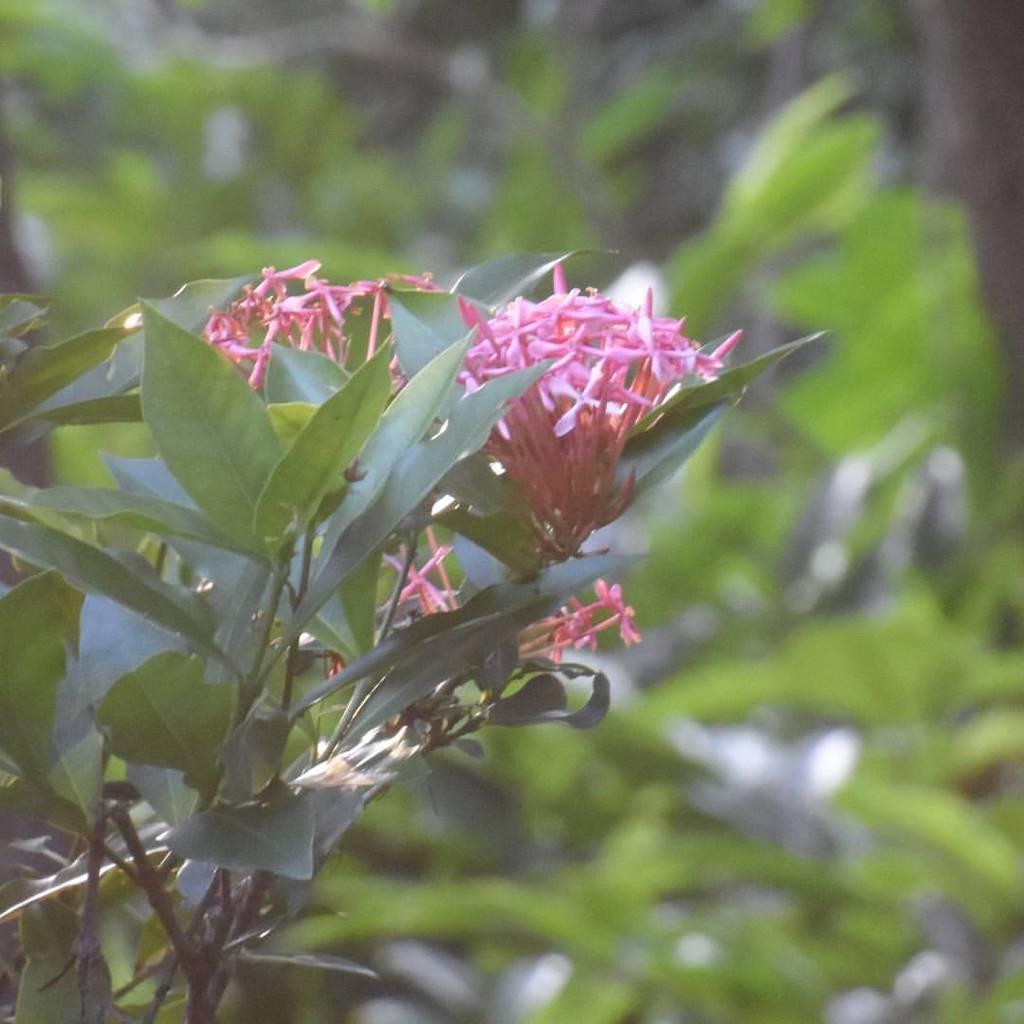Could you give a brief overview of what you see in this image? In this picture we can see a plant and flowers in the front, in the background there are some leaves, we can see a blurry background. 